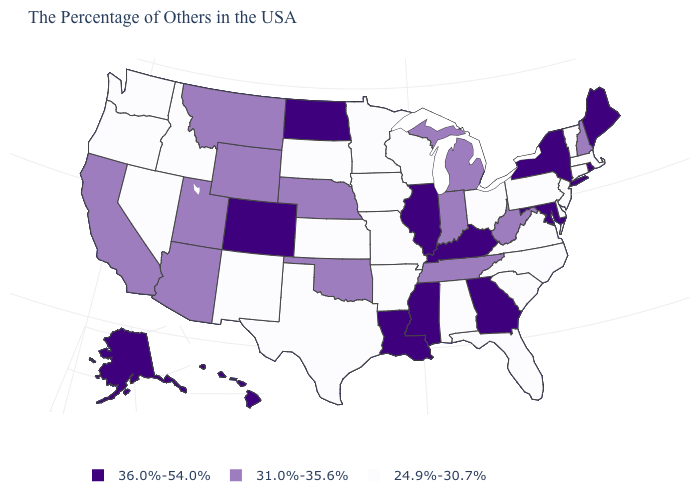What is the highest value in the USA?
Concise answer only. 36.0%-54.0%. Which states have the lowest value in the USA?
Concise answer only. Massachusetts, Vermont, Connecticut, New Jersey, Delaware, Pennsylvania, Virginia, North Carolina, South Carolina, Ohio, Florida, Alabama, Wisconsin, Missouri, Arkansas, Minnesota, Iowa, Kansas, Texas, South Dakota, New Mexico, Idaho, Nevada, Washington, Oregon. What is the value of Maine?
Answer briefly. 36.0%-54.0%. What is the value of South Dakota?
Give a very brief answer. 24.9%-30.7%. What is the value of South Carolina?
Quick response, please. 24.9%-30.7%. Does the first symbol in the legend represent the smallest category?
Quick response, please. No. Which states hav the highest value in the South?
Give a very brief answer. Maryland, Georgia, Kentucky, Mississippi, Louisiana. What is the value of Utah?
Answer briefly. 31.0%-35.6%. Name the states that have a value in the range 36.0%-54.0%?
Be succinct. Maine, Rhode Island, New York, Maryland, Georgia, Kentucky, Illinois, Mississippi, Louisiana, North Dakota, Colorado, Alaska, Hawaii. Name the states that have a value in the range 24.9%-30.7%?
Give a very brief answer. Massachusetts, Vermont, Connecticut, New Jersey, Delaware, Pennsylvania, Virginia, North Carolina, South Carolina, Ohio, Florida, Alabama, Wisconsin, Missouri, Arkansas, Minnesota, Iowa, Kansas, Texas, South Dakota, New Mexico, Idaho, Nevada, Washington, Oregon. Is the legend a continuous bar?
Be succinct. No. Does Wisconsin have the highest value in the USA?
Give a very brief answer. No. What is the highest value in the USA?
Quick response, please. 36.0%-54.0%. Among the states that border New Mexico , which have the lowest value?
Be succinct. Texas. What is the value of Alaska?
Concise answer only. 36.0%-54.0%. 